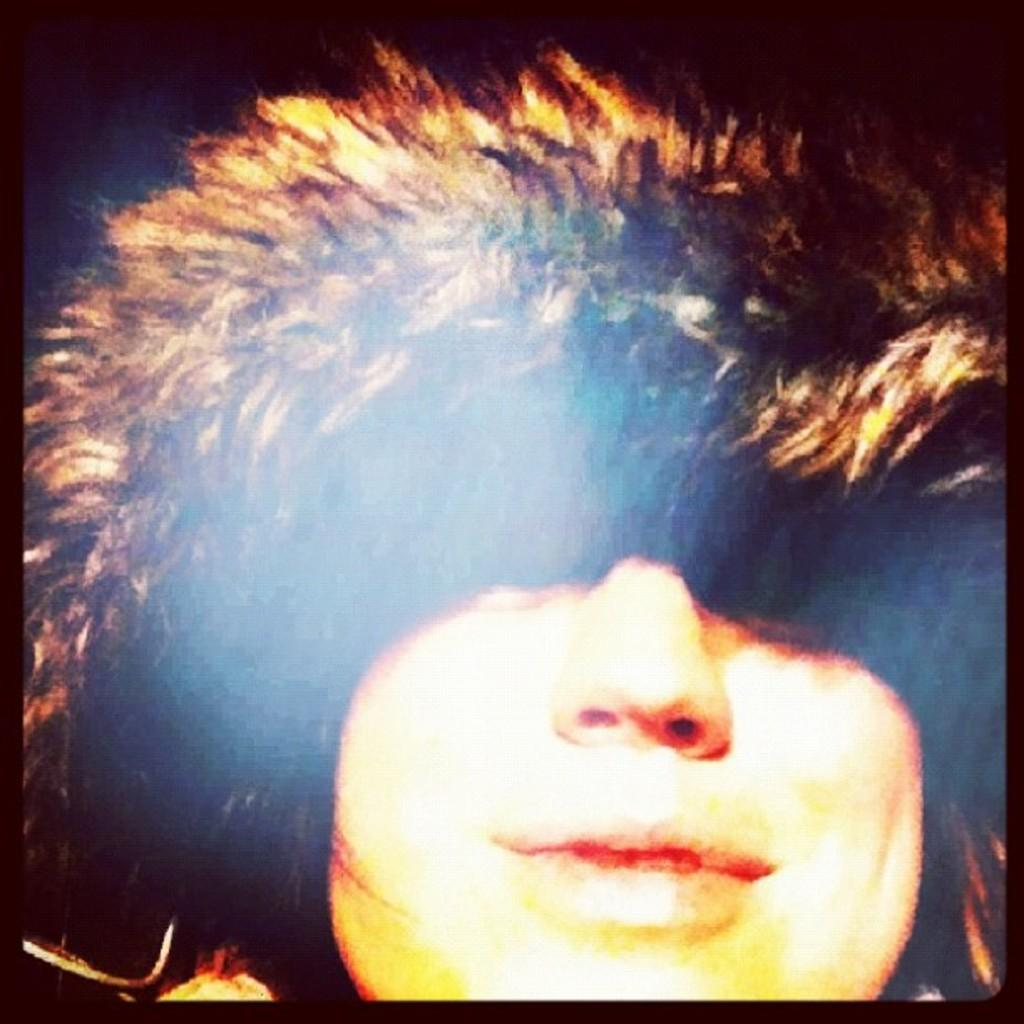Who is present in the image? There is a man in the picture. What is the man wearing? The man is wearing a hoodie. What is the man's facial expression in the image? The man is smiling. How would you describe the lighting at the top of the image? The top of the image appears to be dark. Can you see any cows in the downtown area in the image? There is no downtown area or cow present in the image. 